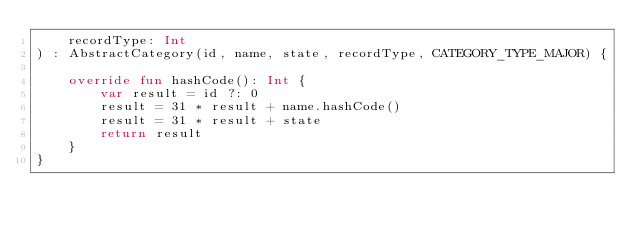Convert code to text. <code><loc_0><loc_0><loc_500><loc_500><_Kotlin_>    recordType: Int
) : AbstractCategory(id, name, state, recordType, CATEGORY_TYPE_MAJOR) {

    override fun hashCode(): Int {
        var result = id ?: 0
        result = 31 * result + name.hashCode()
        result = 31 * result + state
        return result
    }
}</code> 